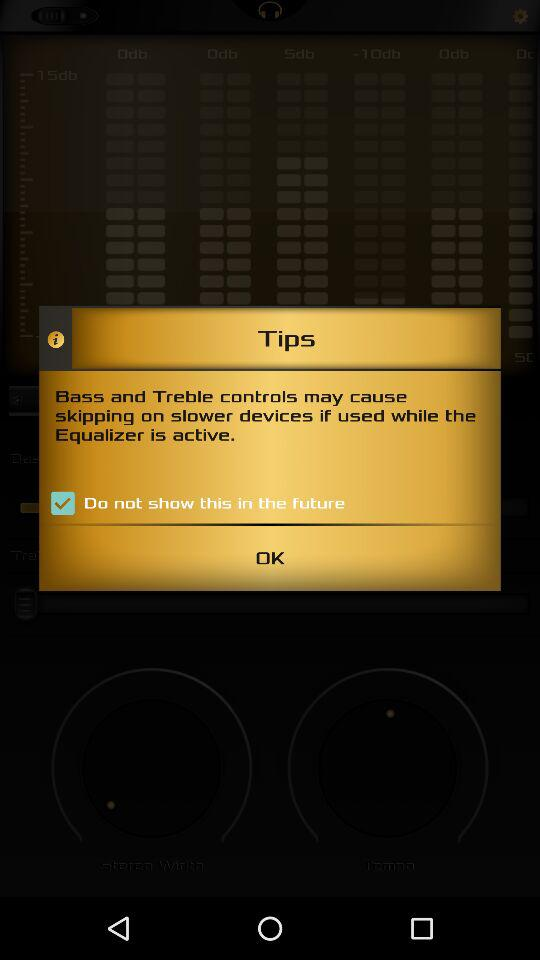What is the status of "Do not show this in the future"? The status is "on". 